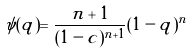Convert formula to latex. <formula><loc_0><loc_0><loc_500><loc_500>\psi ( q ) = \frac { n + 1 } { ( 1 - c ) ^ { n + 1 } } ( 1 - q ) ^ { n }</formula> 